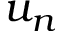Convert formula to latex. <formula><loc_0><loc_0><loc_500><loc_500>u _ { n }</formula> 